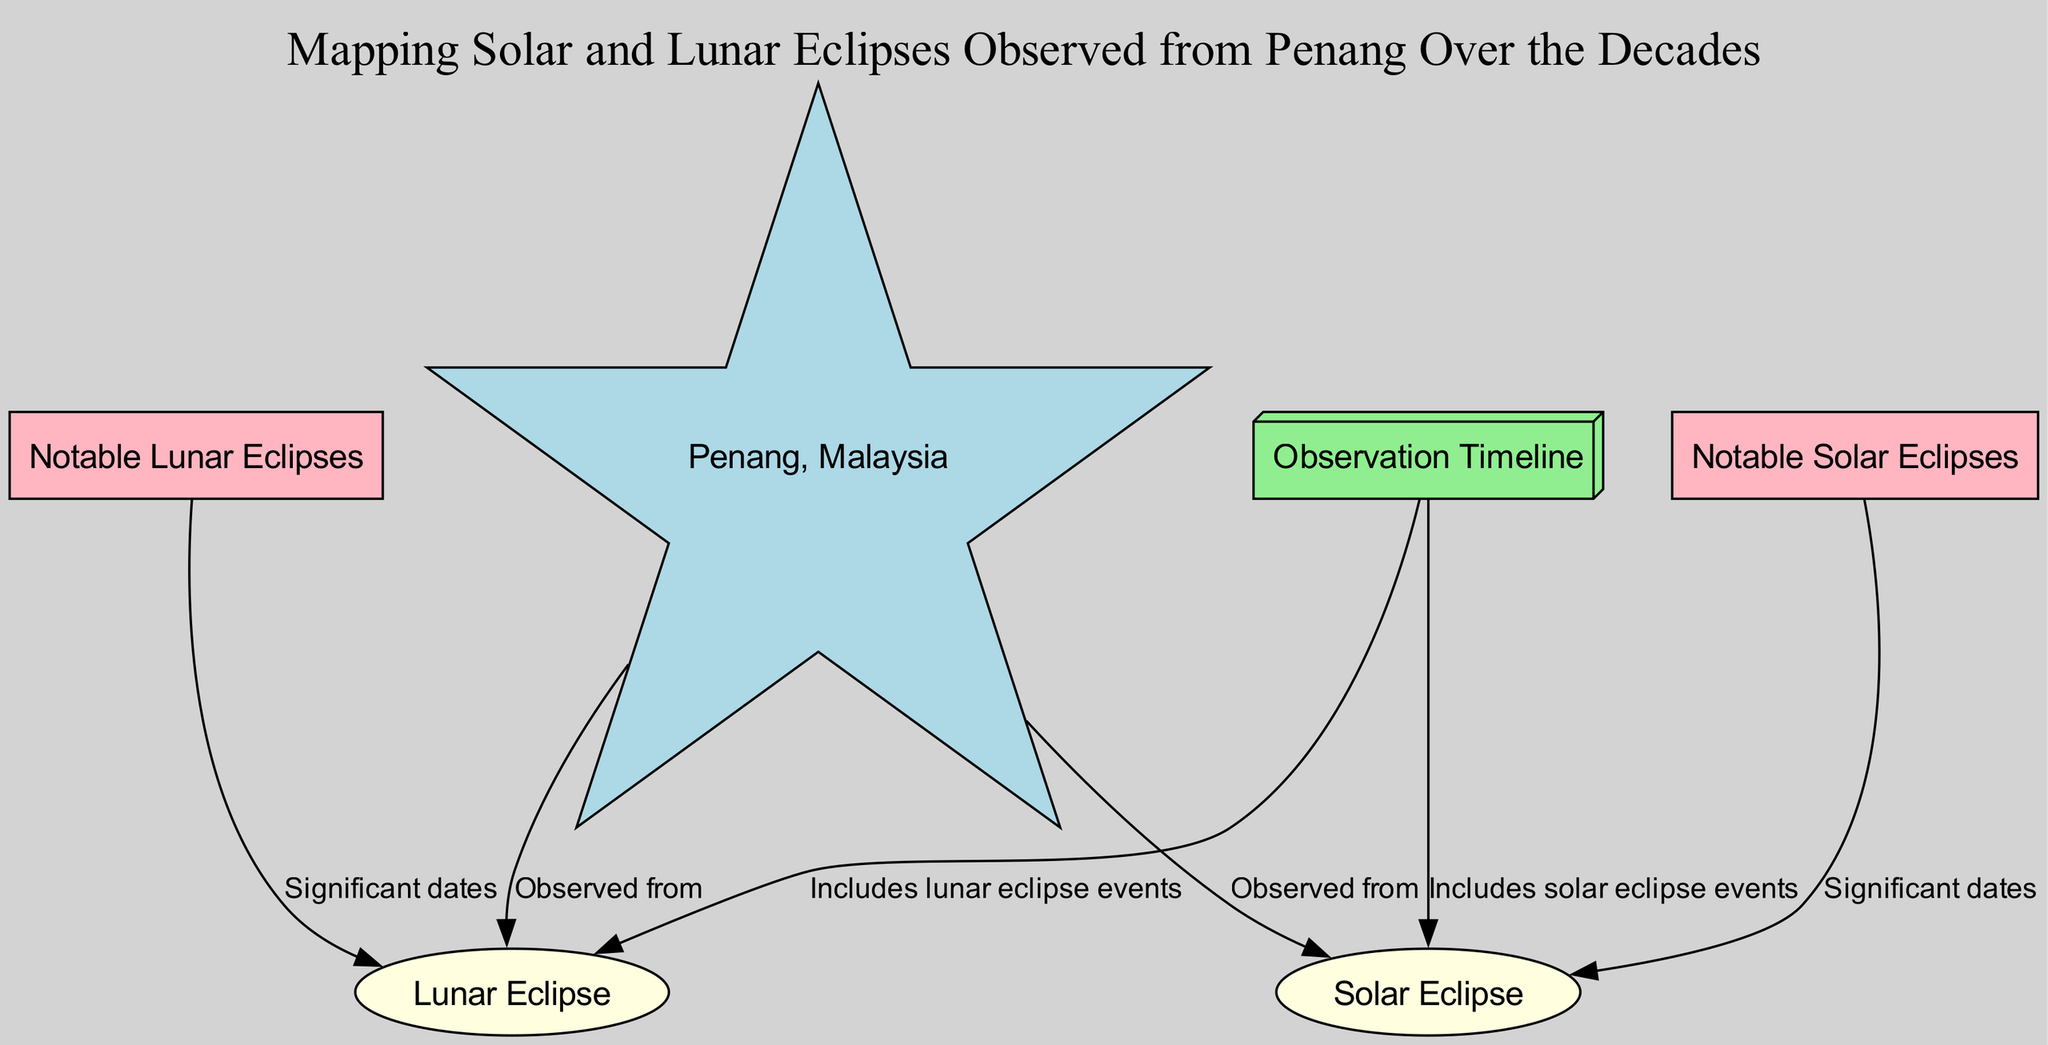What is the geographical location from which the eclipses are observed? The diagram contains a node labeled "Penang, Malaysia," which identifies the specific location for the observations.
Answer: Penang, Malaysia What are the two types of eclipses included in the diagram? By reviewing the nodes in the diagram, two eclipse types are identified: "Solar Eclipse" and "Lunar Eclipse."
Answer: Solar Eclipse, Lunar Eclipse How many notable solar eclipses are mentioned in the diagram? The nodes show a connection between "Notable Solar Eclipses" and "Solar Eclipse," indicating that significant dates for solar eclipses are noted, but the exact number is not specified in the diagram.
Answer: Not specified What is the relationship between Penang and solar eclipses? The edge labeled "Observed from" links "Penang, Malaysia" to "Solar Eclipse," indicating that solar eclipses are observed from this location.
Answer: Observed from Which node represents a chronological record of eclipse events? The node labeled "Observation Timeline" signifies the chronological aspect of recorded eclipse events, connecting to both types of eclipses.
Answer: Observation Timeline How does the observation timeline relate to lunar eclipses? The edge labeled "Includes lunar eclipse events" connects "Observation Timeline" to "Lunar Eclipse," indicating the timeline includes these events.
Answer: Includes lunar eclipse events What shape represents notable lunar eclipses in the diagram? The diagram’s node "Notable Lunar Eclipses" is depicted as an ellipse based on its design, differentiating it from other node shapes.
Answer: Ellipse How are notable dates for solar eclipses categorized in the diagram? The node labeled "Notable Solar Eclipses" connects to "Solar Eclipse," suggesting that it categorizes significant solar eclipse dates observed from Penang.
Answer: Significant solar eclipse dates Which node indicates the type of celestial event where the Earth is between the Sun and the Moon? The node labeled "Lunar Eclipse" explicitly describes the celestial event where the Earth is positioned between the Sun and the Moon.
Answer: Lunar Eclipse 